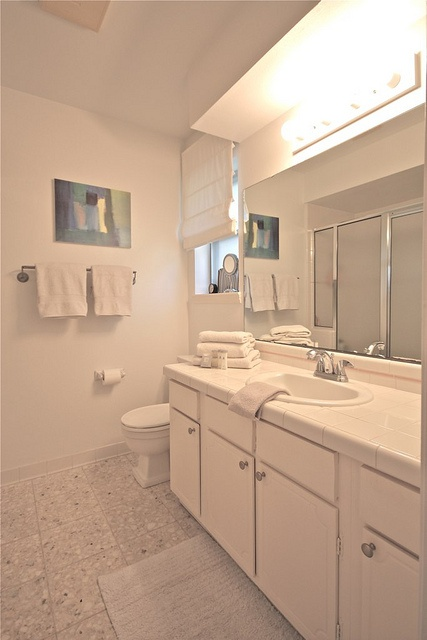Describe the objects in this image and their specific colors. I can see toilet in tan and gray tones and sink in tan and beige tones in this image. 